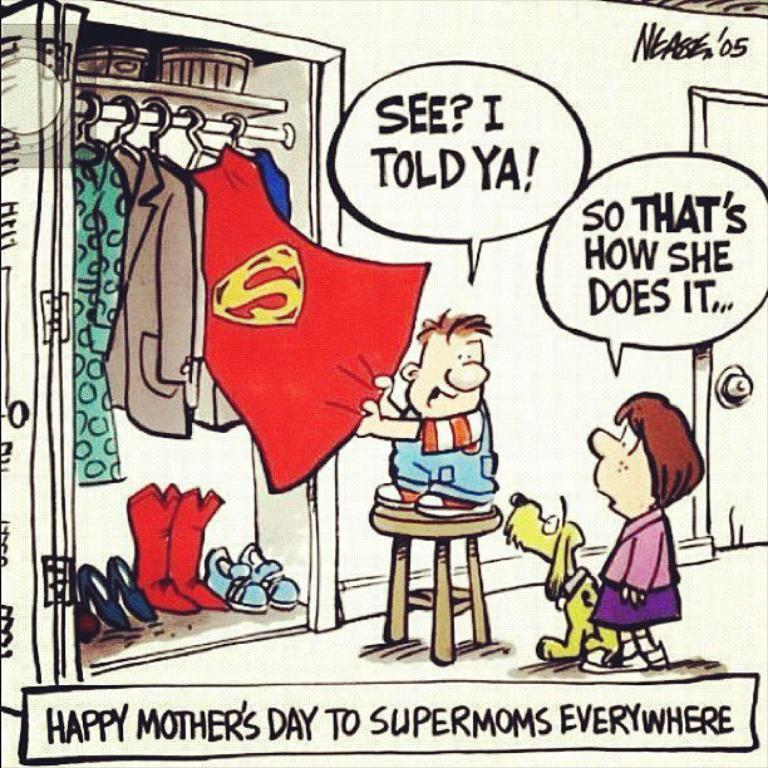Describe this image in one or two sentences. This is a cartoon image. In this image we can see a boy standing on the seating stool, dog and woman standing on the floor, clothes hanged to the hangers, shoes placed in the shoe rack and some text. 